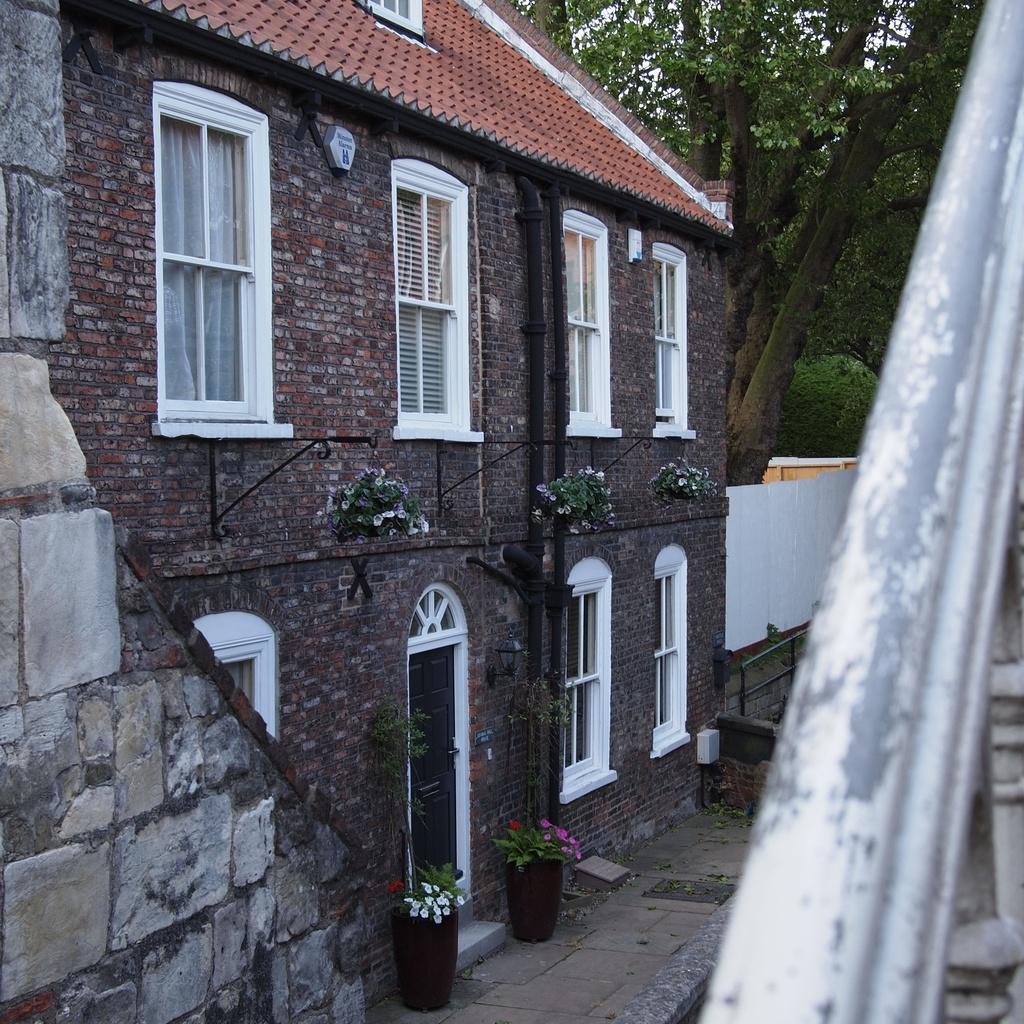Please provide a concise description of this image. To the right side of the image there is a railing. And to the left side of the image there is a building with brick wall, window with curtain, in front of the door there are pots. And in the background there are trees. 